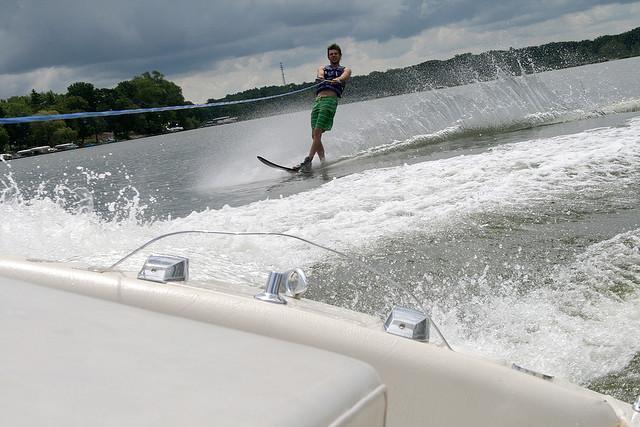What powers the vessel pulling the skier?
From the following four choices, select the correct answer to address the question.
Options: Wind, coal, boat motor, sharks. Boat motor. 